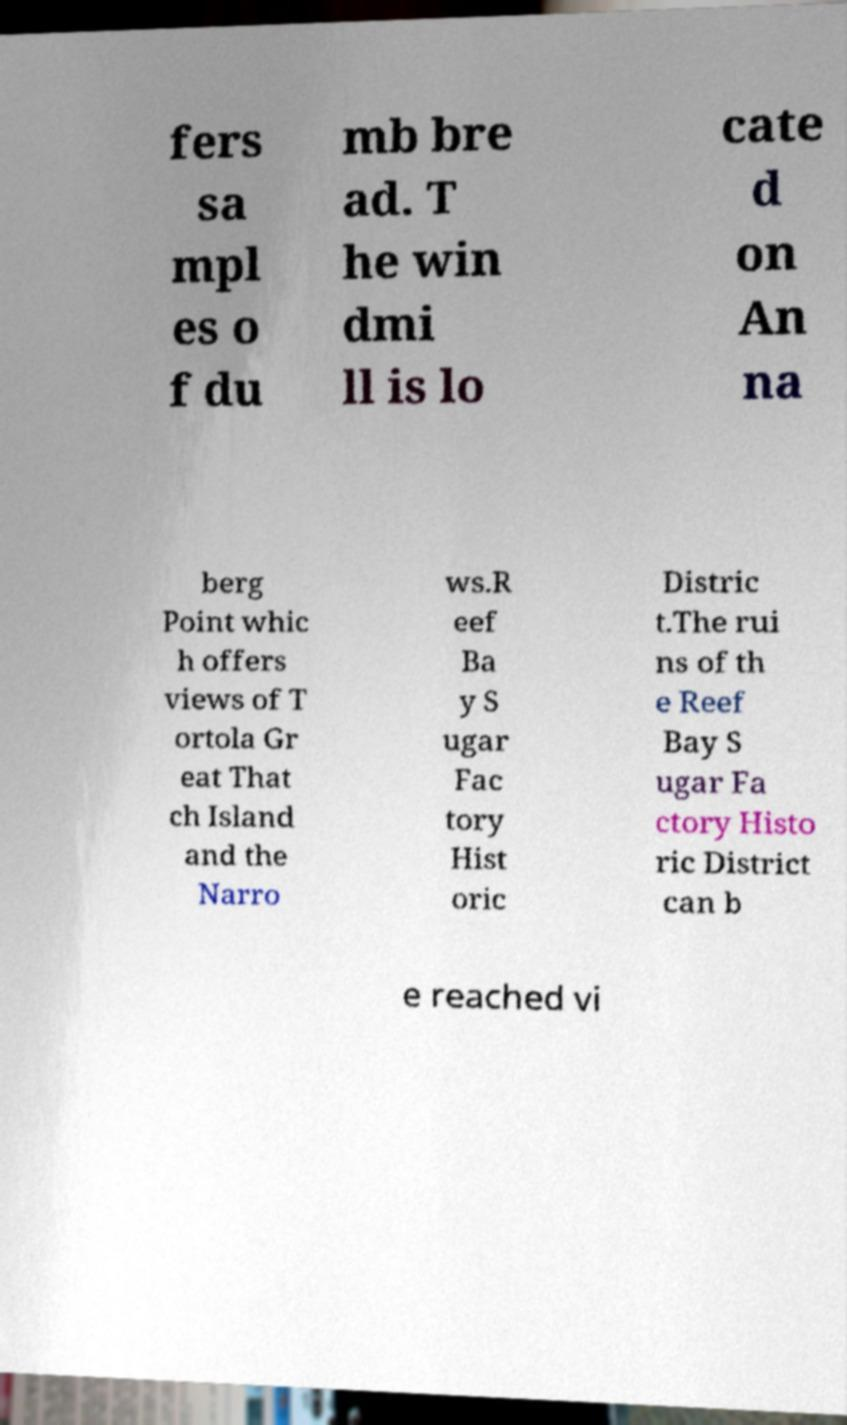Could you extract and type out the text from this image? fers sa mpl es o f du mb bre ad. T he win dmi ll is lo cate d on An na berg Point whic h offers views of T ortola Gr eat That ch Island and the Narro ws.R eef Ba y S ugar Fac tory Hist oric Distric t.The rui ns of th e Reef Bay S ugar Fa ctory Histo ric District can b e reached vi 